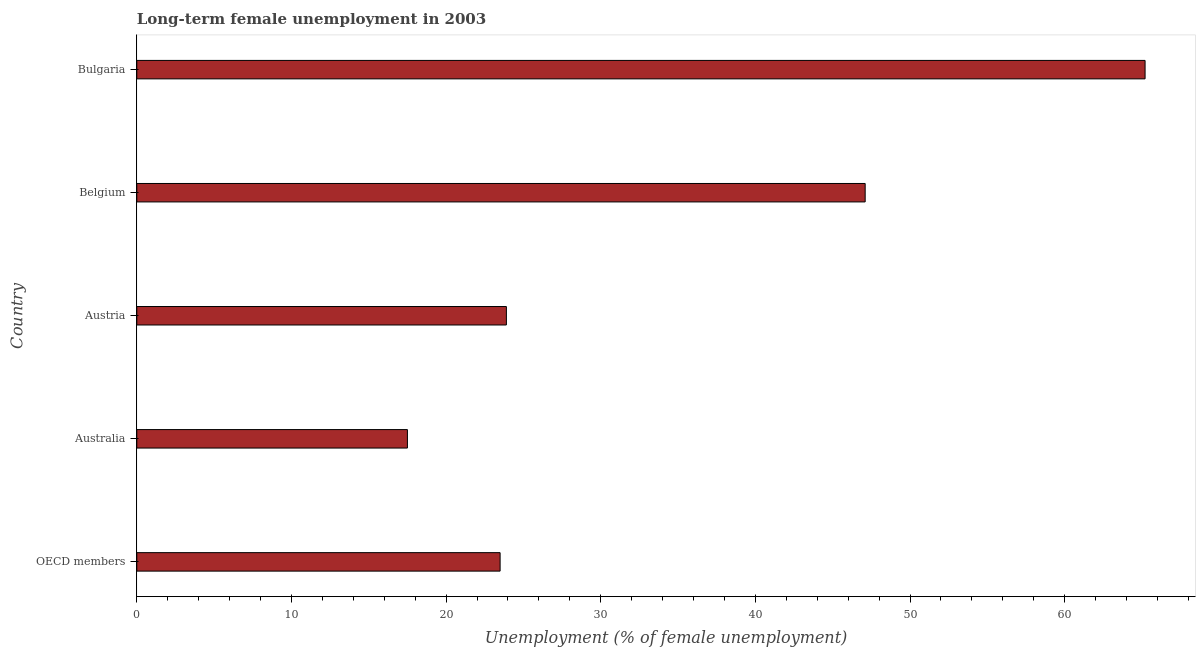Does the graph contain any zero values?
Offer a terse response. No. Does the graph contain grids?
Provide a succinct answer. No. What is the title of the graph?
Give a very brief answer. Long-term female unemployment in 2003. What is the label or title of the X-axis?
Give a very brief answer. Unemployment (% of female unemployment). What is the label or title of the Y-axis?
Offer a terse response. Country. What is the long-term female unemployment in Australia?
Offer a terse response. 17.5. Across all countries, what is the maximum long-term female unemployment?
Provide a short and direct response. 65.2. In which country was the long-term female unemployment minimum?
Give a very brief answer. Australia. What is the sum of the long-term female unemployment?
Keep it short and to the point. 177.19. What is the difference between the long-term female unemployment in Australia and Austria?
Ensure brevity in your answer.  -6.4. What is the average long-term female unemployment per country?
Provide a short and direct response. 35.44. What is the median long-term female unemployment?
Provide a succinct answer. 23.9. In how many countries, is the long-term female unemployment greater than 6 %?
Keep it short and to the point. 5. What is the ratio of the long-term female unemployment in Belgium to that in OECD members?
Your response must be concise. 2. What is the difference between the highest and the second highest long-term female unemployment?
Your answer should be compact. 18.1. What is the difference between the highest and the lowest long-term female unemployment?
Provide a short and direct response. 47.7. In how many countries, is the long-term female unemployment greater than the average long-term female unemployment taken over all countries?
Make the answer very short. 2. How many bars are there?
Your answer should be compact. 5. Are all the bars in the graph horizontal?
Your response must be concise. Yes. How many countries are there in the graph?
Provide a short and direct response. 5. What is the Unemployment (% of female unemployment) of OECD members?
Provide a short and direct response. 23.49. What is the Unemployment (% of female unemployment) in Australia?
Your response must be concise. 17.5. What is the Unemployment (% of female unemployment) of Austria?
Ensure brevity in your answer.  23.9. What is the Unemployment (% of female unemployment) in Belgium?
Provide a short and direct response. 47.1. What is the Unemployment (% of female unemployment) of Bulgaria?
Your response must be concise. 65.2. What is the difference between the Unemployment (% of female unemployment) in OECD members and Australia?
Your answer should be very brief. 5.99. What is the difference between the Unemployment (% of female unemployment) in OECD members and Austria?
Give a very brief answer. -0.41. What is the difference between the Unemployment (% of female unemployment) in OECD members and Belgium?
Your answer should be very brief. -23.61. What is the difference between the Unemployment (% of female unemployment) in OECD members and Bulgaria?
Provide a short and direct response. -41.71. What is the difference between the Unemployment (% of female unemployment) in Australia and Belgium?
Provide a succinct answer. -29.6. What is the difference between the Unemployment (% of female unemployment) in Australia and Bulgaria?
Your response must be concise. -47.7. What is the difference between the Unemployment (% of female unemployment) in Austria and Belgium?
Give a very brief answer. -23.2. What is the difference between the Unemployment (% of female unemployment) in Austria and Bulgaria?
Your answer should be very brief. -41.3. What is the difference between the Unemployment (% of female unemployment) in Belgium and Bulgaria?
Keep it short and to the point. -18.1. What is the ratio of the Unemployment (% of female unemployment) in OECD members to that in Australia?
Keep it short and to the point. 1.34. What is the ratio of the Unemployment (% of female unemployment) in OECD members to that in Belgium?
Your answer should be compact. 0.5. What is the ratio of the Unemployment (% of female unemployment) in OECD members to that in Bulgaria?
Provide a short and direct response. 0.36. What is the ratio of the Unemployment (% of female unemployment) in Australia to that in Austria?
Offer a terse response. 0.73. What is the ratio of the Unemployment (% of female unemployment) in Australia to that in Belgium?
Your response must be concise. 0.37. What is the ratio of the Unemployment (% of female unemployment) in Australia to that in Bulgaria?
Provide a short and direct response. 0.27. What is the ratio of the Unemployment (% of female unemployment) in Austria to that in Belgium?
Your response must be concise. 0.51. What is the ratio of the Unemployment (% of female unemployment) in Austria to that in Bulgaria?
Keep it short and to the point. 0.37. What is the ratio of the Unemployment (% of female unemployment) in Belgium to that in Bulgaria?
Keep it short and to the point. 0.72. 